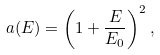Convert formula to latex. <formula><loc_0><loc_0><loc_500><loc_500>a ( E ) = \left ( 1 + \frac { E } { E _ { 0 } } \right ) ^ { 2 } ,</formula> 